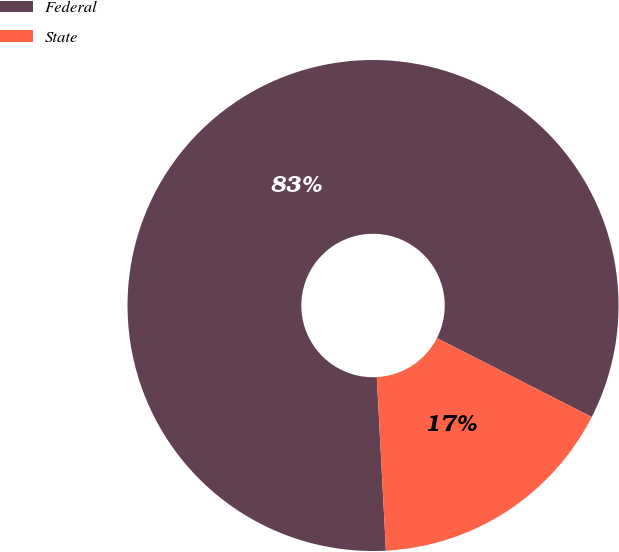Convert chart. <chart><loc_0><loc_0><loc_500><loc_500><pie_chart><fcel>Federal<fcel>State<nl><fcel>83.34%<fcel>16.66%<nl></chart> 